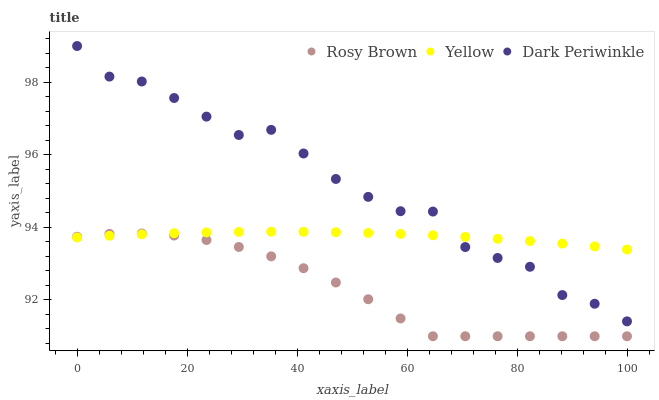Does Rosy Brown have the minimum area under the curve?
Answer yes or no. Yes. Does Dark Periwinkle have the maximum area under the curve?
Answer yes or no. Yes. Does Yellow have the minimum area under the curve?
Answer yes or no. No. Does Yellow have the maximum area under the curve?
Answer yes or no. No. Is Yellow the smoothest?
Answer yes or no. Yes. Is Dark Periwinkle the roughest?
Answer yes or no. Yes. Is Dark Periwinkle the smoothest?
Answer yes or no. No. Is Yellow the roughest?
Answer yes or no. No. Does Rosy Brown have the lowest value?
Answer yes or no. Yes. Does Dark Periwinkle have the lowest value?
Answer yes or no. No. Does Dark Periwinkle have the highest value?
Answer yes or no. Yes. Does Yellow have the highest value?
Answer yes or no. No. Is Rosy Brown less than Dark Periwinkle?
Answer yes or no. Yes. Is Dark Periwinkle greater than Rosy Brown?
Answer yes or no. Yes. Does Dark Periwinkle intersect Yellow?
Answer yes or no. Yes. Is Dark Periwinkle less than Yellow?
Answer yes or no. No. Is Dark Periwinkle greater than Yellow?
Answer yes or no. No. Does Rosy Brown intersect Dark Periwinkle?
Answer yes or no. No. 